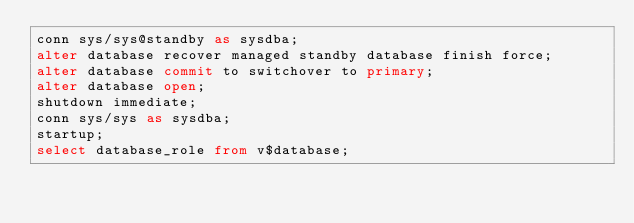<code> <loc_0><loc_0><loc_500><loc_500><_SQL_>conn sys/sys@standby as sysdba;
alter database recover managed standby database finish force;
alter database commit to switchover to primary;
alter database open;
shutdown immediate;
conn sys/sys as sysdba;
startup;
select database_role from v$database;
</code> 